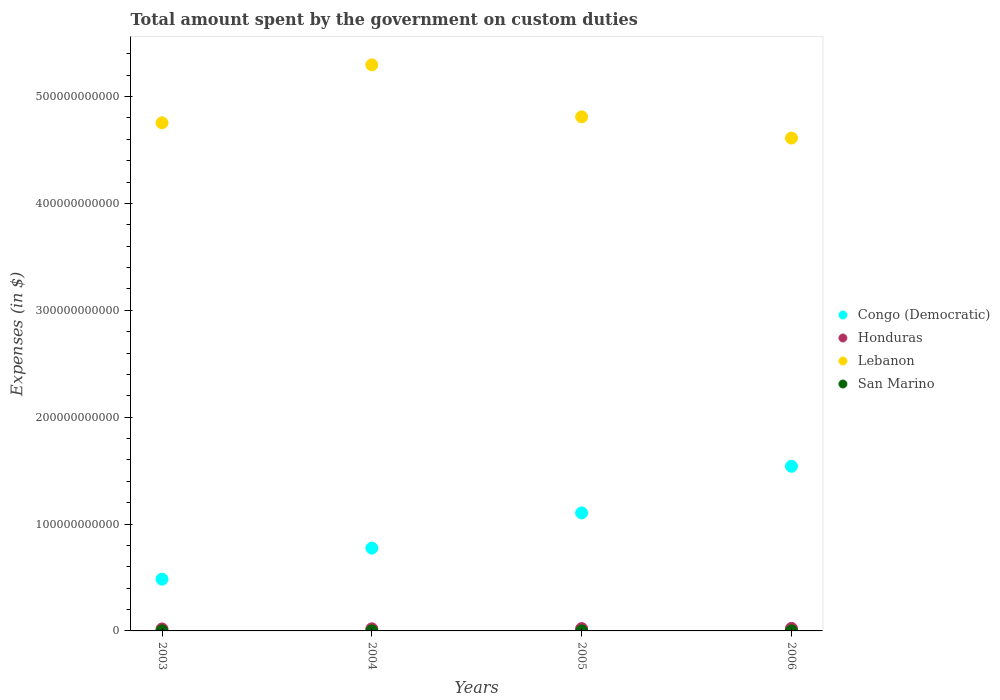What is the amount spent on custom duties by the government in Lebanon in 2004?
Keep it short and to the point. 5.30e+11. Across all years, what is the maximum amount spent on custom duties by the government in San Marino?
Provide a succinct answer. 1.01e+07. Across all years, what is the minimum amount spent on custom duties by the government in Congo (Democratic)?
Provide a short and direct response. 4.84e+1. In which year was the amount spent on custom duties by the government in Congo (Democratic) maximum?
Make the answer very short. 2006. In which year was the amount spent on custom duties by the government in Lebanon minimum?
Your answer should be compact. 2006. What is the total amount spent on custom duties by the government in Honduras in the graph?
Make the answer very short. 8.32e+09. What is the difference between the amount spent on custom duties by the government in San Marino in 2003 and that in 2006?
Your answer should be compact. -6.27e+06. What is the difference between the amount spent on custom duties by the government in San Marino in 2004 and the amount spent on custom duties by the government in Lebanon in 2005?
Keep it short and to the point. -4.81e+11. What is the average amount spent on custom duties by the government in Honduras per year?
Keep it short and to the point. 2.08e+09. In the year 2004, what is the difference between the amount spent on custom duties by the government in San Marino and amount spent on custom duties by the government in Lebanon?
Offer a very short reply. -5.30e+11. What is the ratio of the amount spent on custom duties by the government in Lebanon in 2003 to that in 2005?
Your answer should be very brief. 0.99. Is the difference between the amount spent on custom duties by the government in San Marino in 2003 and 2005 greater than the difference between the amount spent on custom duties by the government in Lebanon in 2003 and 2005?
Make the answer very short. Yes. What is the difference between the highest and the second highest amount spent on custom duties by the government in Lebanon?
Offer a terse response. 4.86e+1. What is the difference between the highest and the lowest amount spent on custom duties by the government in San Marino?
Offer a terse response. 6.27e+06. In how many years, is the amount spent on custom duties by the government in Congo (Democratic) greater than the average amount spent on custom duties by the government in Congo (Democratic) taken over all years?
Your response must be concise. 2. Is it the case that in every year, the sum of the amount spent on custom duties by the government in Congo (Democratic) and amount spent on custom duties by the government in San Marino  is greater than the sum of amount spent on custom duties by the government in Lebanon and amount spent on custom duties by the government in Honduras?
Provide a succinct answer. No. Is the amount spent on custom duties by the government in Congo (Democratic) strictly greater than the amount spent on custom duties by the government in San Marino over the years?
Make the answer very short. Yes. How many dotlines are there?
Offer a terse response. 4. What is the difference between two consecutive major ticks on the Y-axis?
Offer a terse response. 1.00e+11. Does the graph contain any zero values?
Provide a succinct answer. No. Where does the legend appear in the graph?
Make the answer very short. Center right. How are the legend labels stacked?
Offer a terse response. Vertical. What is the title of the graph?
Offer a terse response. Total amount spent by the government on custom duties. Does "Mexico" appear as one of the legend labels in the graph?
Offer a terse response. No. What is the label or title of the X-axis?
Your response must be concise. Years. What is the label or title of the Y-axis?
Keep it short and to the point. Expenses (in $). What is the Expenses (in $) in Congo (Democratic) in 2003?
Your answer should be very brief. 4.84e+1. What is the Expenses (in $) of Honduras in 2003?
Keep it short and to the point. 1.83e+09. What is the Expenses (in $) of Lebanon in 2003?
Offer a very short reply. 4.75e+11. What is the Expenses (in $) of San Marino in 2003?
Provide a succinct answer. 3.79e+06. What is the Expenses (in $) of Congo (Democratic) in 2004?
Provide a succinct answer. 7.75e+1. What is the Expenses (in $) of Honduras in 2004?
Offer a very short reply. 1.95e+09. What is the Expenses (in $) in Lebanon in 2004?
Keep it short and to the point. 5.30e+11. What is the Expenses (in $) in San Marino in 2004?
Ensure brevity in your answer.  5.95e+06. What is the Expenses (in $) in Congo (Democratic) in 2005?
Keep it short and to the point. 1.10e+11. What is the Expenses (in $) of Honduras in 2005?
Your answer should be compact. 2.18e+09. What is the Expenses (in $) of Lebanon in 2005?
Keep it short and to the point. 4.81e+11. What is the Expenses (in $) of San Marino in 2005?
Offer a terse response. 8.54e+06. What is the Expenses (in $) in Congo (Democratic) in 2006?
Keep it short and to the point. 1.54e+11. What is the Expenses (in $) of Honduras in 2006?
Your answer should be very brief. 2.35e+09. What is the Expenses (in $) of Lebanon in 2006?
Make the answer very short. 4.61e+11. What is the Expenses (in $) in San Marino in 2006?
Provide a succinct answer. 1.01e+07. Across all years, what is the maximum Expenses (in $) in Congo (Democratic)?
Keep it short and to the point. 1.54e+11. Across all years, what is the maximum Expenses (in $) in Honduras?
Make the answer very short. 2.35e+09. Across all years, what is the maximum Expenses (in $) of Lebanon?
Offer a terse response. 5.30e+11. Across all years, what is the maximum Expenses (in $) of San Marino?
Make the answer very short. 1.01e+07. Across all years, what is the minimum Expenses (in $) of Congo (Democratic)?
Offer a very short reply. 4.84e+1. Across all years, what is the minimum Expenses (in $) in Honduras?
Keep it short and to the point. 1.83e+09. Across all years, what is the minimum Expenses (in $) of Lebanon?
Your answer should be compact. 4.61e+11. Across all years, what is the minimum Expenses (in $) of San Marino?
Make the answer very short. 3.79e+06. What is the total Expenses (in $) in Congo (Democratic) in the graph?
Provide a short and direct response. 3.90e+11. What is the total Expenses (in $) of Honduras in the graph?
Your answer should be compact. 8.32e+09. What is the total Expenses (in $) in Lebanon in the graph?
Provide a succinct answer. 1.95e+12. What is the total Expenses (in $) in San Marino in the graph?
Ensure brevity in your answer.  2.83e+07. What is the difference between the Expenses (in $) of Congo (Democratic) in 2003 and that in 2004?
Your answer should be compact. -2.91e+1. What is the difference between the Expenses (in $) in Honduras in 2003 and that in 2004?
Give a very brief answer. -1.19e+08. What is the difference between the Expenses (in $) of Lebanon in 2003 and that in 2004?
Provide a succinct answer. -5.42e+1. What is the difference between the Expenses (in $) in San Marino in 2003 and that in 2004?
Make the answer very short. -2.17e+06. What is the difference between the Expenses (in $) of Congo (Democratic) in 2003 and that in 2005?
Your response must be concise. -6.20e+1. What is the difference between the Expenses (in $) of Honduras in 2003 and that in 2005?
Make the answer very short. -3.46e+08. What is the difference between the Expenses (in $) in Lebanon in 2003 and that in 2005?
Make the answer very short. -5.57e+09. What is the difference between the Expenses (in $) of San Marino in 2003 and that in 2005?
Keep it short and to the point. -4.75e+06. What is the difference between the Expenses (in $) of Congo (Democratic) in 2003 and that in 2006?
Offer a terse response. -1.06e+11. What is the difference between the Expenses (in $) in Honduras in 2003 and that in 2006?
Offer a terse response. -5.20e+08. What is the difference between the Expenses (in $) of Lebanon in 2003 and that in 2006?
Your response must be concise. 1.43e+1. What is the difference between the Expenses (in $) in San Marino in 2003 and that in 2006?
Give a very brief answer. -6.27e+06. What is the difference between the Expenses (in $) of Congo (Democratic) in 2004 and that in 2005?
Your answer should be very brief. -3.29e+1. What is the difference between the Expenses (in $) in Honduras in 2004 and that in 2005?
Give a very brief answer. -2.27e+08. What is the difference between the Expenses (in $) of Lebanon in 2004 and that in 2005?
Keep it short and to the point. 4.86e+1. What is the difference between the Expenses (in $) of San Marino in 2004 and that in 2005?
Offer a terse response. -2.58e+06. What is the difference between the Expenses (in $) of Congo (Democratic) in 2004 and that in 2006?
Offer a very short reply. -7.66e+1. What is the difference between the Expenses (in $) of Honduras in 2004 and that in 2006?
Your answer should be very brief. -4.01e+08. What is the difference between the Expenses (in $) of Lebanon in 2004 and that in 2006?
Your answer should be very brief. 6.85e+1. What is the difference between the Expenses (in $) of San Marino in 2004 and that in 2006?
Your answer should be very brief. -4.10e+06. What is the difference between the Expenses (in $) in Congo (Democratic) in 2005 and that in 2006?
Offer a terse response. -4.36e+1. What is the difference between the Expenses (in $) of Honduras in 2005 and that in 2006?
Ensure brevity in your answer.  -1.74e+08. What is the difference between the Expenses (in $) in Lebanon in 2005 and that in 2006?
Provide a succinct answer. 1.98e+1. What is the difference between the Expenses (in $) in San Marino in 2005 and that in 2006?
Your answer should be very brief. -1.51e+06. What is the difference between the Expenses (in $) in Congo (Democratic) in 2003 and the Expenses (in $) in Honduras in 2004?
Keep it short and to the point. 4.65e+1. What is the difference between the Expenses (in $) of Congo (Democratic) in 2003 and the Expenses (in $) of Lebanon in 2004?
Offer a very short reply. -4.81e+11. What is the difference between the Expenses (in $) in Congo (Democratic) in 2003 and the Expenses (in $) in San Marino in 2004?
Give a very brief answer. 4.84e+1. What is the difference between the Expenses (in $) of Honduras in 2003 and the Expenses (in $) of Lebanon in 2004?
Offer a very short reply. -5.28e+11. What is the difference between the Expenses (in $) in Honduras in 2003 and the Expenses (in $) in San Marino in 2004?
Your answer should be very brief. 1.83e+09. What is the difference between the Expenses (in $) of Lebanon in 2003 and the Expenses (in $) of San Marino in 2004?
Offer a terse response. 4.75e+11. What is the difference between the Expenses (in $) of Congo (Democratic) in 2003 and the Expenses (in $) of Honduras in 2005?
Keep it short and to the point. 4.62e+1. What is the difference between the Expenses (in $) in Congo (Democratic) in 2003 and the Expenses (in $) in Lebanon in 2005?
Provide a succinct answer. -4.33e+11. What is the difference between the Expenses (in $) in Congo (Democratic) in 2003 and the Expenses (in $) in San Marino in 2005?
Give a very brief answer. 4.84e+1. What is the difference between the Expenses (in $) in Honduras in 2003 and the Expenses (in $) in Lebanon in 2005?
Your response must be concise. -4.79e+11. What is the difference between the Expenses (in $) in Honduras in 2003 and the Expenses (in $) in San Marino in 2005?
Offer a very short reply. 1.82e+09. What is the difference between the Expenses (in $) in Lebanon in 2003 and the Expenses (in $) in San Marino in 2005?
Your answer should be compact. 4.75e+11. What is the difference between the Expenses (in $) in Congo (Democratic) in 2003 and the Expenses (in $) in Honduras in 2006?
Provide a short and direct response. 4.61e+1. What is the difference between the Expenses (in $) in Congo (Democratic) in 2003 and the Expenses (in $) in Lebanon in 2006?
Provide a succinct answer. -4.13e+11. What is the difference between the Expenses (in $) of Congo (Democratic) in 2003 and the Expenses (in $) of San Marino in 2006?
Keep it short and to the point. 4.84e+1. What is the difference between the Expenses (in $) in Honduras in 2003 and the Expenses (in $) in Lebanon in 2006?
Give a very brief answer. -4.59e+11. What is the difference between the Expenses (in $) of Honduras in 2003 and the Expenses (in $) of San Marino in 2006?
Keep it short and to the point. 1.82e+09. What is the difference between the Expenses (in $) in Lebanon in 2003 and the Expenses (in $) in San Marino in 2006?
Offer a very short reply. 4.75e+11. What is the difference between the Expenses (in $) of Congo (Democratic) in 2004 and the Expenses (in $) of Honduras in 2005?
Give a very brief answer. 7.53e+1. What is the difference between the Expenses (in $) of Congo (Democratic) in 2004 and the Expenses (in $) of Lebanon in 2005?
Give a very brief answer. -4.04e+11. What is the difference between the Expenses (in $) in Congo (Democratic) in 2004 and the Expenses (in $) in San Marino in 2005?
Make the answer very short. 7.75e+1. What is the difference between the Expenses (in $) of Honduras in 2004 and the Expenses (in $) of Lebanon in 2005?
Ensure brevity in your answer.  -4.79e+11. What is the difference between the Expenses (in $) of Honduras in 2004 and the Expenses (in $) of San Marino in 2005?
Provide a short and direct response. 1.94e+09. What is the difference between the Expenses (in $) of Lebanon in 2004 and the Expenses (in $) of San Marino in 2005?
Your answer should be very brief. 5.30e+11. What is the difference between the Expenses (in $) in Congo (Democratic) in 2004 and the Expenses (in $) in Honduras in 2006?
Provide a short and direct response. 7.51e+1. What is the difference between the Expenses (in $) of Congo (Democratic) in 2004 and the Expenses (in $) of Lebanon in 2006?
Offer a terse response. -3.84e+11. What is the difference between the Expenses (in $) of Congo (Democratic) in 2004 and the Expenses (in $) of San Marino in 2006?
Offer a terse response. 7.75e+1. What is the difference between the Expenses (in $) in Honduras in 2004 and the Expenses (in $) in Lebanon in 2006?
Provide a short and direct response. -4.59e+11. What is the difference between the Expenses (in $) of Honduras in 2004 and the Expenses (in $) of San Marino in 2006?
Make the answer very short. 1.94e+09. What is the difference between the Expenses (in $) in Lebanon in 2004 and the Expenses (in $) in San Marino in 2006?
Make the answer very short. 5.30e+11. What is the difference between the Expenses (in $) in Congo (Democratic) in 2005 and the Expenses (in $) in Honduras in 2006?
Your answer should be very brief. 1.08e+11. What is the difference between the Expenses (in $) of Congo (Democratic) in 2005 and the Expenses (in $) of Lebanon in 2006?
Your answer should be compact. -3.51e+11. What is the difference between the Expenses (in $) of Congo (Democratic) in 2005 and the Expenses (in $) of San Marino in 2006?
Your answer should be compact. 1.10e+11. What is the difference between the Expenses (in $) of Honduras in 2005 and the Expenses (in $) of Lebanon in 2006?
Give a very brief answer. -4.59e+11. What is the difference between the Expenses (in $) of Honduras in 2005 and the Expenses (in $) of San Marino in 2006?
Your answer should be very brief. 2.17e+09. What is the difference between the Expenses (in $) in Lebanon in 2005 and the Expenses (in $) in San Marino in 2006?
Ensure brevity in your answer.  4.81e+11. What is the average Expenses (in $) of Congo (Democratic) per year?
Ensure brevity in your answer.  9.76e+1. What is the average Expenses (in $) of Honduras per year?
Your answer should be very brief. 2.08e+09. What is the average Expenses (in $) of Lebanon per year?
Your response must be concise. 4.87e+11. What is the average Expenses (in $) in San Marino per year?
Keep it short and to the point. 7.08e+06. In the year 2003, what is the difference between the Expenses (in $) in Congo (Democratic) and Expenses (in $) in Honduras?
Provide a short and direct response. 4.66e+1. In the year 2003, what is the difference between the Expenses (in $) of Congo (Democratic) and Expenses (in $) of Lebanon?
Your answer should be very brief. -4.27e+11. In the year 2003, what is the difference between the Expenses (in $) in Congo (Democratic) and Expenses (in $) in San Marino?
Your response must be concise. 4.84e+1. In the year 2003, what is the difference between the Expenses (in $) in Honduras and Expenses (in $) in Lebanon?
Give a very brief answer. -4.74e+11. In the year 2003, what is the difference between the Expenses (in $) of Honduras and Expenses (in $) of San Marino?
Offer a very short reply. 1.83e+09. In the year 2003, what is the difference between the Expenses (in $) of Lebanon and Expenses (in $) of San Marino?
Keep it short and to the point. 4.75e+11. In the year 2004, what is the difference between the Expenses (in $) in Congo (Democratic) and Expenses (in $) in Honduras?
Give a very brief answer. 7.55e+1. In the year 2004, what is the difference between the Expenses (in $) in Congo (Democratic) and Expenses (in $) in Lebanon?
Your response must be concise. -4.52e+11. In the year 2004, what is the difference between the Expenses (in $) in Congo (Democratic) and Expenses (in $) in San Marino?
Give a very brief answer. 7.75e+1. In the year 2004, what is the difference between the Expenses (in $) of Honduras and Expenses (in $) of Lebanon?
Give a very brief answer. -5.28e+11. In the year 2004, what is the difference between the Expenses (in $) of Honduras and Expenses (in $) of San Marino?
Provide a short and direct response. 1.95e+09. In the year 2004, what is the difference between the Expenses (in $) in Lebanon and Expenses (in $) in San Marino?
Offer a terse response. 5.30e+11. In the year 2005, what is the difference between the Expenses (in $) in Congo (Democratic) and Expenses (in $) in Honduras?
Give a very brief answer. 1.08e+11. In the year 2005, what is the difference between the Expenses (in $) of Congo (Democratic) and Expenses (in $) of Lebanon?
Provide a short and direct response. -3.71e+11. In the year 2005, what is the difference between the Expenses (in $) of Congo (Democratic) and Expenses (in $) of San Marino?
Provide a succinct answer. 1.10e+11. In the year 2005, what is the difference between the Expenses (in $) in Honduras and Expenses (in $) in Lebanon?
Make the answer very short. -4.79e+11. In the year 2005, what is the difference between the Expenses (in $) in Honduras and Expenses (in $) in San Marino?
Your answer should be compact. 2.17e+09. In the year 2005, what is the difference between the Expenses (in $) of Lebanon and Expenses (in $) of San Marino?
Give a very brief answer. 4.81e+11. In the year 2006, what is the difference between the Expenses (in $) in Congo (Democratic) and Expenses (in $) in Honduras?
Make the answer very short. 1.52e+11. In the year 2006, what is the difference between the Expenses (in $) of Congo (Democratic) and Expenses (in $) of Lebanon?
Your answer should be very brief. -3.07e+11. In the year 2006, what is the difference between the Expenses (in $) in Congo (Democratic) and Expenses (in $) in San Marino?
Keep it short and to the point. 1.54e+11. In the year 2006, what is the difference between the Expenses (in $) of Honduras and Expenses (in $) of Lebanon?
Provide a short and direct response. -4.59e+11. In the year 2006, what is the difference between the Expenses (in $) of Honduras and Expenses (in $) of San Marino?
Offer a terse response. 2.34e+09. In the year 2006, what is the difference between the Expenses (in $) of Lebanon and Expenses (in $) of San Marino?
Offer a terse response. 4.61e+11. What is the ratio of the Expenses (in $) in Congo (Democratic) in 2003 to that in 2004?
Your answer should be very brief. 0.62. What is the ratio of the Expenses (in $) of Honduras in 2003 to that in 2004?
Keep it short and to the point. 0.94. What is the ratio of the Expenses (in $) in Lebanon in 2003 to that in 2004?
Your answer should be compact. 0.9. What is the ratio of the Expenses (in $) in San Marino in 2003 to that in 2004?
Your answer should be very brief. 0.64. What is the ratio of the Expenses (in $) in Congo (Democratic) in 2003 to that in 2005?
Ensure brevity in your answer.  0.44. What is the ratio of the Expenses (in $) of Honduras in 2003 to that in 2005?
Provide a short and direct response. 0.84. What is the ratio of the Expenses (in $) in Lebanon in 2003 to that in 2005?
Keep it short and to the point. 0.99. What is the ratio of the Expenses (in $) of San Marino in 2003 to that in 2005?
Give a very brief answer. 0.44. What is the ratio of the Expenses (in $) in Congo (Democratic) in 2003 to that in 2006?
Make the answer very short. 0.31. What is the ratio of the Expenses (in $) in Honduras in 2003 to that in 2006?
Your answer should be compact. 0.78. What is the ratio of the Expenses (in $) in Lebanon in 2003 to that in 2006?
Make the answer very short. 1.03. What is the ratio of the Expenses (in $) in San Marino in 2003 to that in 2006?
Provide a succinct answer. 0.38. What is the ratio of the Expenses (in $) of Congo (Democratic) in 2004 to that in 2005?
Your answer should be very brief. 0.7. What is the ratio of the Expenses (in $) in Honduras in 2004 to that in 2005?
Your response must be concise. 0.9. What is the ratio of the Expenses (in $) in Lebanon in 2004 to that in 2005?
Offer a very short reply. 1.1. What is the ratio of the Expenses (in $) of San Marino in 2004 to that in 2005?
Offer a terse response. 0.7. What is the ratio of the Expenses (in $) of Congo (Democratic) in 2004 to that in 2006?
Make the answer very short. 0.5. What is the ratio of the Expenses (in $) in Honduras in 2004 to that in 2006?
Provide a succinct answer. 0.83. What is the ratio of the Expenses (in $) of Lebanon in 2004 to that in 2006?
Provide a succinct answer. 1.15. What is the ratio of the Expenses (in $) of San Marino in 2004 to that in 2006?
Provide a short and direct response. 0.59. What is the ratio of the Expenses (in $) of Congo (Democratic) in 2005 to that in 2006?
Your response must be concise. 0.72. What is the ratio of the Expenses (in $) in Honduras in 2005 to that in 2006?
Give a very brief answer. 0.93. What is the ratio of the Expenses (in $) of Lebanon in 2005 to that in 2006?
Make the answer very short. 1.04. What is the ratio of the Expenses (in $) in San Marino in 2005 to that in 2006?
Provide a short and direct response. 0.85. What is the difference between the highest and the second highest Expenses (in $) in Congo (Democratic)?
Your answer should be compact. 4.36e+1. What is the difference between the highest and the second highest Expenses (in $) of Honduras?
Provide a short and direct response. 1.74e+08. What is the difference between the highest and the second highest Expenses (in $) of Lebanon?
Offer a very short reply. 4.86e+1. What is the difference between the highest and the second highest Expenses (in $) of San Marino?
Your response must be concise. 1.51e+06. What is the difference between the highest and the lowest Expenses (in $) of Congo (Democratic)?
Your answer should be very brief. 1.06e+11. What is the difference between the highest and the lowest Expenses (in $) in Honduras?
Provide a short and direct response. 5.20e+08. What is the difference between the highest and the lowest Expenses (in $) in Lebanon?
Make the answer very short. 6.85e+1. What is the difference between the highest and the lowest Expenses (in $) of San Marino?
Give a very brief answer. 6.27e+06. 